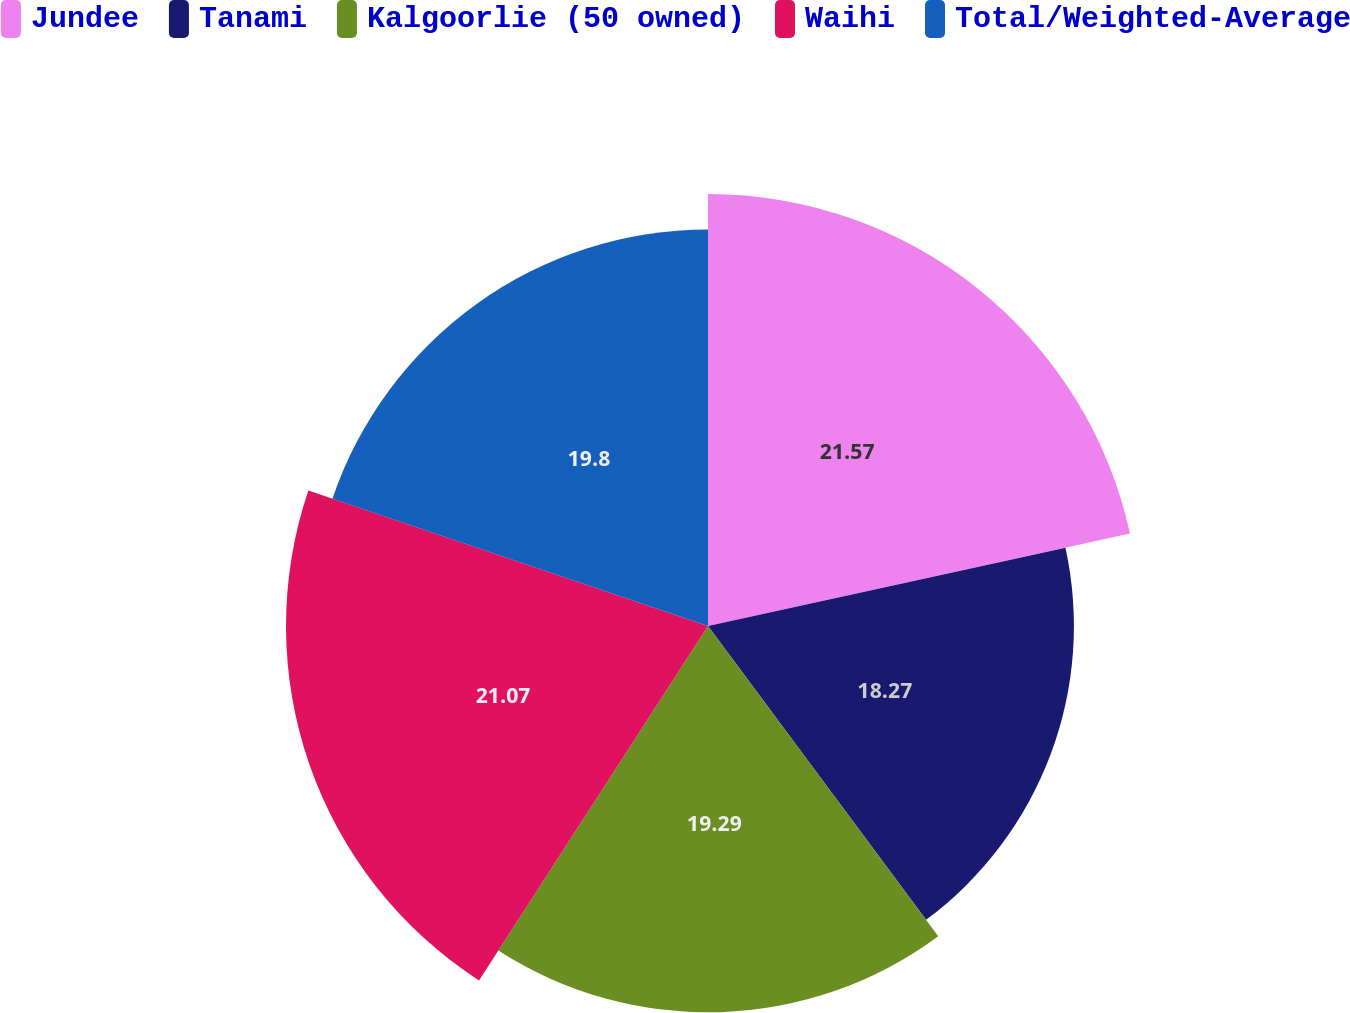Convert chart. <chart><loc_0><loc_0><loc_500><loc_500><pie_chart><fcel>Jundee<fcel>Tanami<fcel>Kalgoorlie (50 owned)<fcel>Waihi<fcel>Total/Weighted-Average<nl><fcel>21.57%<fcel>18.27%<fcel>19.29%<fcel>21.07%<fcel>19.8%<nl></chart> 